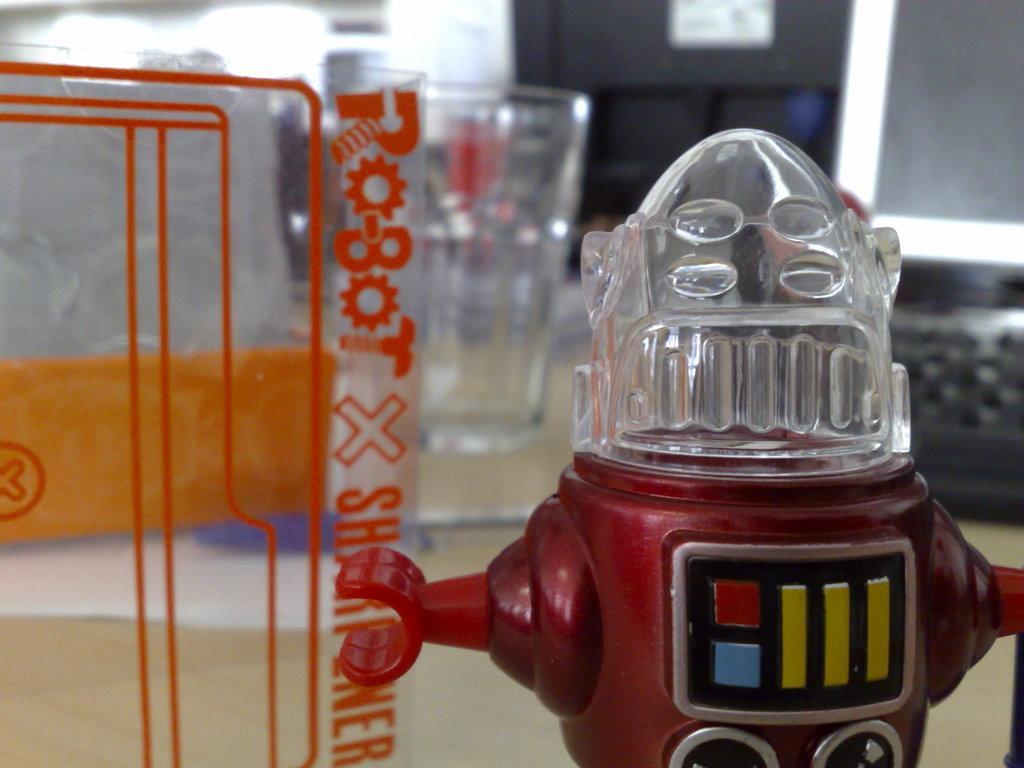<image>
Provide a brief description of the given image. a vintage robot character next to a sign saying robot x 